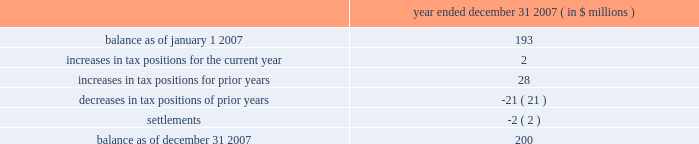Determined that it will primarily be subject to the ietu in future periods , and as such it has recorded tax expense of approximately $ 20 million in 2007 for the deferred tax effects of the new ietu system .
As of december 31 , 2007 , the company had us federal net operating loss carryforwards of approximately $ 206 million which will begin to expire in 2023 .
Of this amount , $ 47 million relates to the pre-acquisition period and is subject to limitation .
The remaining $ 159 million is subject to limitation as a result of the change in stock ownership in may 2006 .
This limitation is not expected to have a material impact on utilization of the net operating loss carryforwards .
The company also had foreign net operating loss carryforwards as of december 31 , 2007 of approximately $ 564 million for canada , germany , mexico and other foreign jurisdictions with various expiration dates .
Net operating losses in canada have various carryforward periods and began expiring in 2007 .
Net operating losses in germany have no expiration date .
Net operating losses in mexico have a ten year carryforward period and begin to expire in 2009 .
However , these losses are not available for use under the new ietu tax regulations in mexico .
As the ietu is the primary system upon which the company will be subject to tax in future periods , no deferred tax asset has been reflected in the balance sheet as of december 31 , 2007 for these income tax loss carryforwards .
The company adopted the provisions of fin 48 effective january 1 , 2007 .
Fin 48 clarifies the accounting for income taxes by prescribing a minimum recognition threshold a tax benefit is required to meet before being recognized in the financial statements .
Fin 48 also provides guidance on derecognition , measurement , classification , interest and penalties , accounting in interim periods , disclosure and transition .
As a result of the implementation of fin 48 , the company increased retained earnings by $ 14 million and decreased goodwill by $ 2 million .
In addition , certain tax liabilities for unrecognized tax benefits , as well as related potential penalties and interest , were reclassified from current liabilities to long-term liabilities .
Liabilities for unrecognized tax benefits as of december 31 , 2007 relate to various us and foreign jurisdictions .
A reconciliation of the beginning and ending amount of unrecognized tax benefits is as follows : year ended december 31 , 2007 ( in $ millions ) .
Included in the unrecognized tax benefits of $ 200 million as of december 31 , 2007 is $ 56 million of tax benefits that , if recognized , would reduce the company 2019s effective tax rate .
The company recognizes interest and penalties related to unrecognized tax benefits in the provision for income taxes .
As of december 31 , 2007 , the company has recorded a liability of approximately $ 36 million for interest and penalties .
This amount includes an increase of approximately $ 13 million for the year ended december 31 , 2007 .
The company operates in the united states ( including multiple state jurisdictions ) , germany and approximately 40 other foreign jurisdictions including canada , china , france , mexico and singapore .
Examinations are ongoing in a number of those jurisdictions including , most significantly , in germany for the years 2001 to 2004 .
During the quarter ended march 31 , 2007 , the company received final assessments in germany for the prior examination period , 1997 to 2000 .
The effective settlement of those examinations resulted in a reduction to goodwill of approximately $ 42 million with a net expected cash outlay of $ 29 million .
The company 2019s celanese corporation and subsidiaries notes to consolidated financial statements 2014 ( continued ) %%transmsg*** transmitting job : y48011 pcn : 122000000 ***%%pcmsg|f-49 |00023|yes|no|02/26/2008 22:07|0|0|page is valid , no graphics -- color : d| .
What portion of the balance of unrecognized tax benefits as of december 31 , 2007 would affect the effective tax rate if it is recognized? 
Computations: (56 / 200)
Answer: 0.28. 